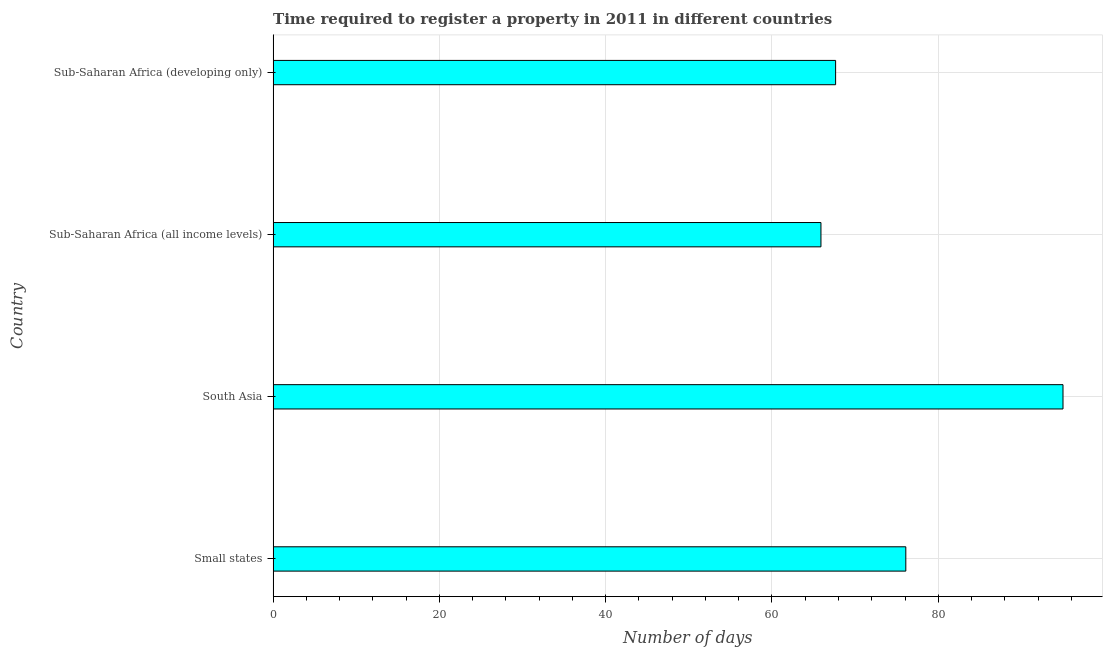Does the graph contain grids?
Offer a terse response. Yes. What is the title of the graph?
Make the answer very short. Time required to register a property in 2011 in different countries. What is the label or title of the X-axis?
Give a very brief answer. Number of days. What is the label or title of the Y-axis?
Offer a very short reply. Country. What is the number of days required to register property in Sub-Saharan Africa (all income levels)?
Provide a short and direct response. 65.89. Across all countries, what is the minimum number of days required to register property?
Provide a succinct answer. 65.89. In which country was the number of days required to register property minimum?
Your answer should be compact. Sub-Saharan Africa (all income levels). What is the sum of the number of days required to register property?
Ensure brevity in your answer.  304.63. What is the difference between the number of days required to register property in Small states and Sub-Saharan Africa (developing only)?
Your answer should be compact. 8.44. What is the average number of days required to register property per country?
Keep it short and to the point. 76.16. What is the median number of days required to register property?
Offer a terse response. 71.87. What is the ratio of the number of days required to register property in Small states to that in Sub-Saharan Africa (all income levels)?
Your answer should be very brief. 1.16. What is the difference between the highest and the second highest number of days required to register property?
Make the answer very short. 18.91. Is the sum of the number of days required to register property in South Asia and Sub-Saharan Africa (all income levels) greater than the maximum number of days required to register property across all countries?
Ensure brevity in your answer.  Yes. What is the difference between the highest and the lowest number of days required to register property?
Offer a terse response. 29.11. How many bars are there?
Offer a terse response. 4. What is the difference between two consecutive major ticks on the X-axis?
Your response must be concise. 20. What is the Number of days in Small states?
Ensure brevity in your answer.  76.09. What is the Number of days of Sub-Saharan Africa (all income levels)?
Provide a short and direct response. 65.89. What is the Number of days in Sub-Saharan Africa (developing only)?
Provide a short and direct response. 67.65. What is the difference between the Number of days in Small states and South Asia?
Make the answer very short. -18.91. What is the difference between the Number of days in Small states and Sub-Saharan Africa (all income levels)?
Your answer should be very brief. 10.21. What is the difference between the Number of days in Small states and Sub-Saharan Africa (developing only)?
Your response must be concise. 8.44. What is the difference between the Number of days in South Asia and Sub-Saharan Africa (all income levels)?
Offer a terse response. 29.11. What is the difference between the Number of days in South Asia and Sub-Saharan Africa (developing only)?
Make the answer very short. 27.35. What is the difference between the Number of days in Sub-Saharan Africa (all income levels) and Sub-Saharan Africa (developing only)?
Provide a short and direct response. -1.76. What is the ratio of the Number of days in Small states to that in South Asia?
Make the answer very short. 0.8. What is the ratio of the Number of days in Small states to that in Sub-Saharan Africa (all income levels)?
Ensure brevity in your answer.  1.16. What is the ratio of the Number of days in South Asia to that in Sub-Saharan Africa (all income levels)?
Give a very brief answer. 1.44. What is the ratio of the Number of days in South Asia to that in Sub-Saharan Africa (developing only)?
Provide a succinct answer. 1.4. What is the ratio of the Number of days in Sub-Saharan Africa (all income levels) to that in Sub-Saharan Africa (developing only)?
Offer a very short reply. 0.97. 